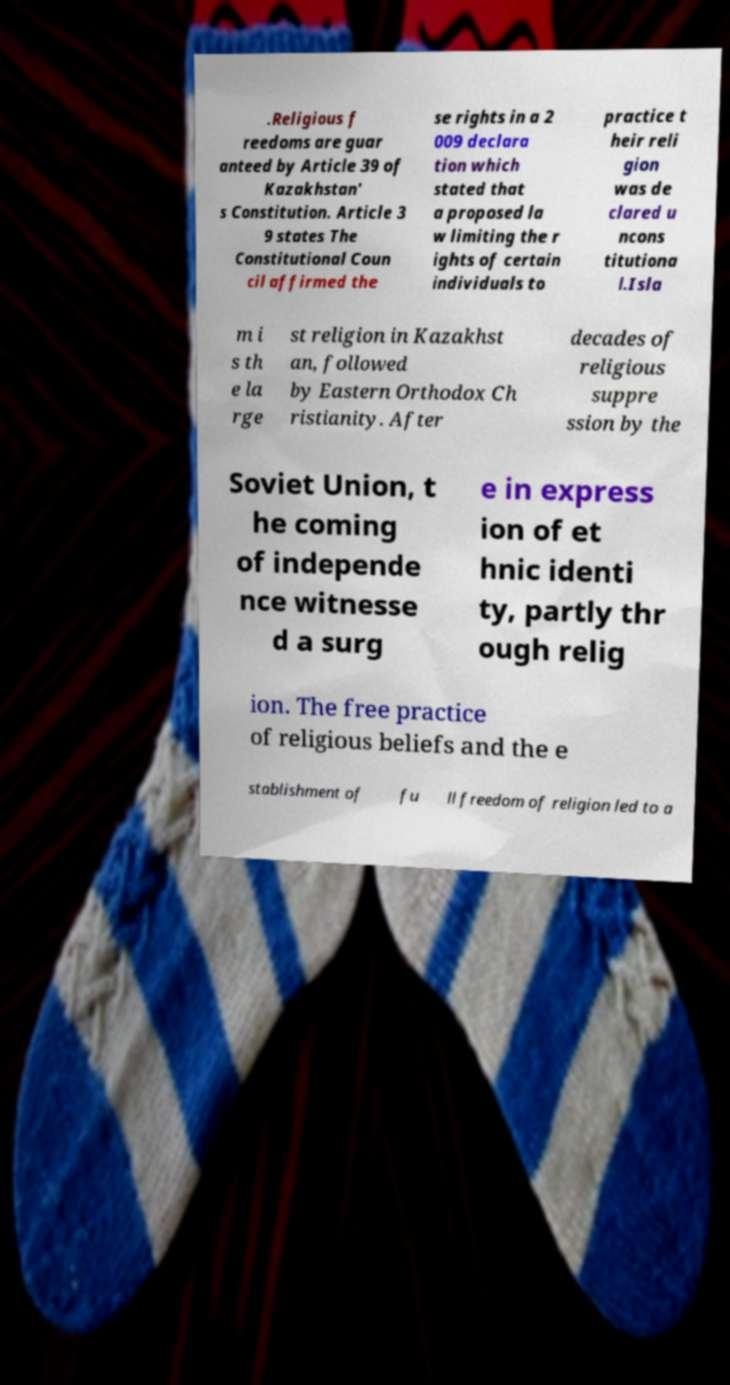Please identify and transcribe the text found in this image. .Religious f reedoms are guar anteed by Article 39 of Kazakhstan' s Constitution. Article 3 9 states The Constitutional Coun cil affirmed the se rights in a 2 009 declara tion which stated that a proposed la w limiting the r ights of certain individuals to practice t heir reli gion was de clared u ncons titutiona l.Isla m i s th e la rge st religion in Kazakhst an, followed by Eastern Orthodox Ch ristianity. After decades of religious suppre ssion by the Soviet Union, t he coming of independe nce witnesse d a surg e in express ion of et hnic identi ty, partly thr ough relig ion. The free practice of religious beliefs and the e stablishment of fu ll freedom of religion led to a 